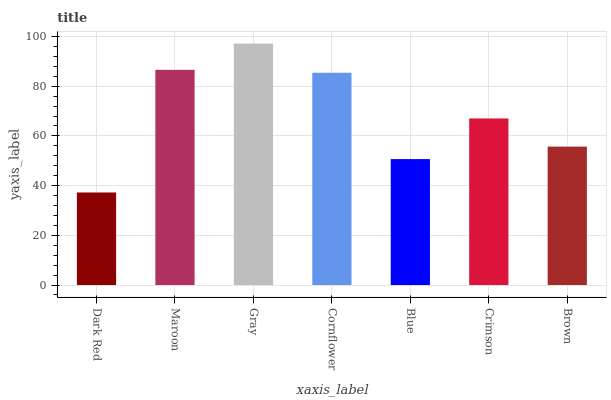Is Dark Red the minimum?
Answer yes or no. Yes. Is Gray the maximum?
Answer yes or no. Yes. Is Maroon the minimum?
Answer yes or no. No. Is Maroon the maximum?
Answer yes or no. No. Is Maroon greater than Dark Red?
Answer yes or no. Yes. Is Dark Red less than Maroon?
Answer yes or no. Yes. Is Dark Red greater than Maroon?
Answer yes or no. No. Is Maroon less than Dark Red?
Answer yes or no. No. Is Crimson the high median?
Answer yes or no. Yes. Is Crimson the low median?
Answer yes or no. Yes. Is Dark Red the high median?
Answer yes or no. No. Is Dark Red the low median?
Answer yes or no. No. 